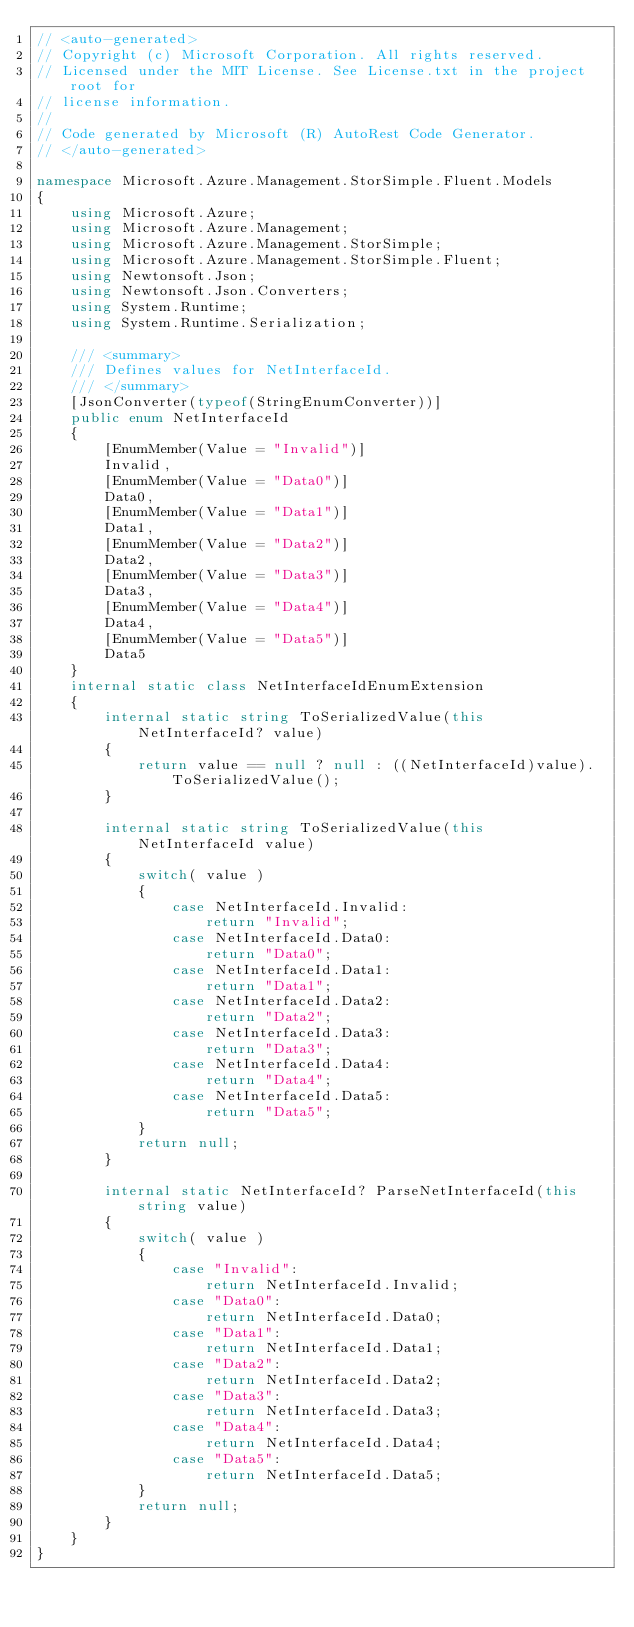Convert code to text. <code><loc_0><loc_0><loc_500><loc_500><_C#_>// <auto-generated>
// Copyright (c) Microsoft Corporation. All rights reserved.
// Licensed under the MIT License. See License.txt in the project root for
// license information.
//
// Code generated by Microsoft (R) AutoRest Code Generator.
// </auto-generated>

namespace Microsoft.Azure.Management.StorSimple.Fluent.Models
{
    using Microsoft.Azure;
    using Microsoft.Azure.Management;
    using Microsoft.Azure.Management.StorSimple;
    using Microsoft.Azure.Management.StorSimple.Fluent;
    using Newtonsoft.Json;
    using Newtonsoft.Json.Converters;
    using System.Runtime;
    using System.Runtime.Serialization;

    /// <summary>
    /// Defines values for NetInterfaceId.
    /// </summary>
    [JsonConverter(typeof(StringEnumConverter))]
    public enum NetInterfaceId
    {
        [EnumMember(Value = "Invalid")]
        Invalid,
        [EnumMember(Value = "Data0")]
        Data0,
        [EnumMember(Value = "Data1")]
        Data1,
        [EnumMember(Value = "Data2")]
        Data2,
        [EnumMember(Value = "Data3")]
        Data3,
        [EnumMember(Value = "Data4")]
        Data4,
        [EnumMember(Value = "Data5")]
        Data5
    }
    internal static class NetInterfaceIdEnumExtension
    {
        internal static string ToSerializedValue(this NetInterfaceId? value)
        {
            return value == null ? null : ((NetInterfaceId)value).ToSerializedValue();
        }

        internal static string ToSerializedValue(this NetInterfaceId value)
        {
            switch( value )
            {
                case NetInterfaceId.Invalid:
                    return "Invalid";
                case NetInterfaceId.Data0:
                    return "Data0";
                case NetInterfaceId.Data1:
                    return "Data1";
                case NetInterfaceId.Data2:
                    return "Data2";
                case NetInterfaceId.Data3:
                    return "Data3";
                case NetInterfaceId.Data4:
                    return "Data4";
                case NetInterfaceId.Data5:
                    return "Data5";
            }
            return null;
        }

        internal static NetInterfaceId? ParseNetInterfaceId(this string value)
        {
            switch( value )
            {
                case "Invalid":
                    return NetInterfaceId.Invalid;
                case "Data0":
                    return NetInterfaceId.Data0;
                case "Data1":
                    return NetInterfaceId.Data1;
                case "Data2":
                    return NetInterfaceId.Data2;
                case "Data3":
                    return NetInterfaceId.Data3;
                case "Data4":
                    return NetInterfaceId.Data4;
                case "Data5":
                    return NetInterfaceId.Data5;
            }
            return null;
        }
    }
}
</code> 